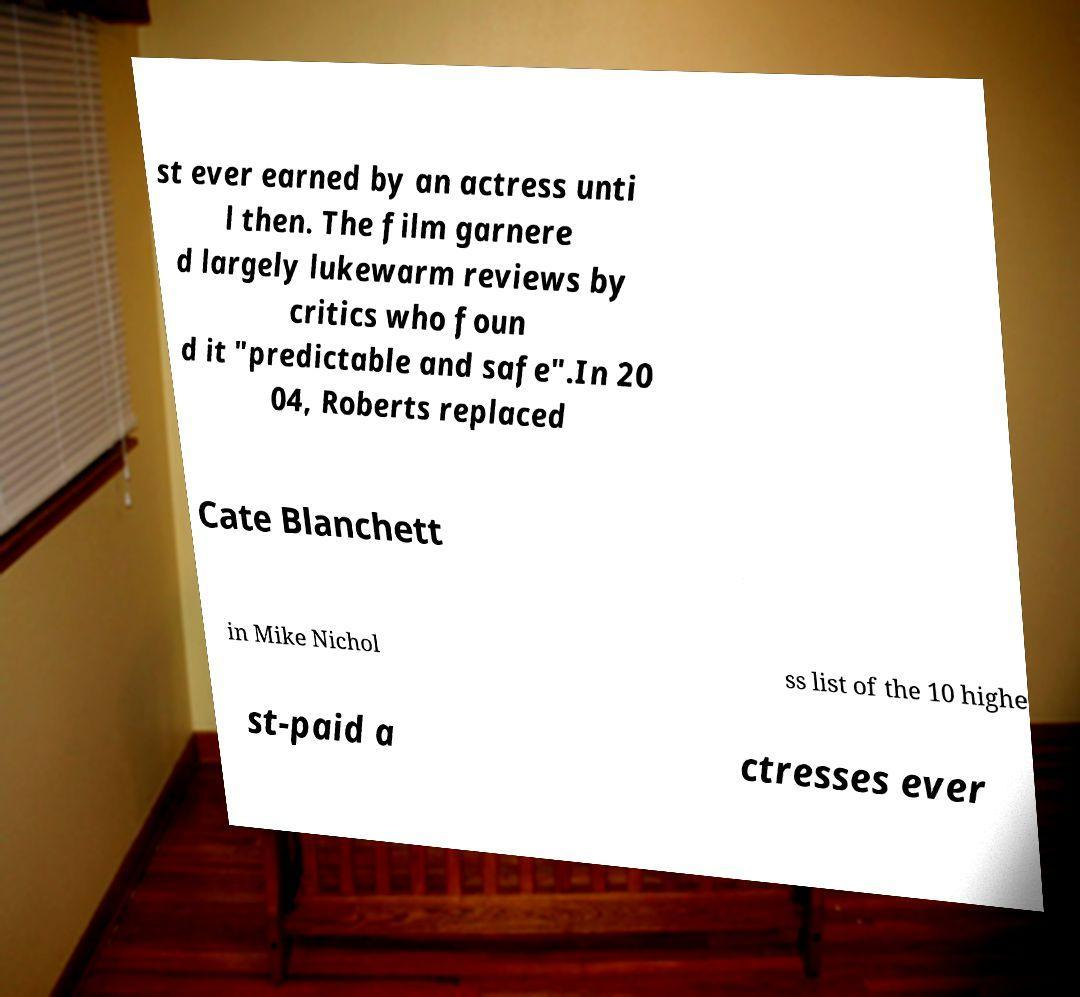What messages or text are displayed in this image? I need them in a readable, typed format. st ever earned by an actress unti l then. The film garnere d largely lukewarm reviews by critics who foun d it "predictable and safe".In 20 04, Roberts replaced Cate Blanchett in Mike Nichol ss list of the 10 highe st-paid a ctresses ever 